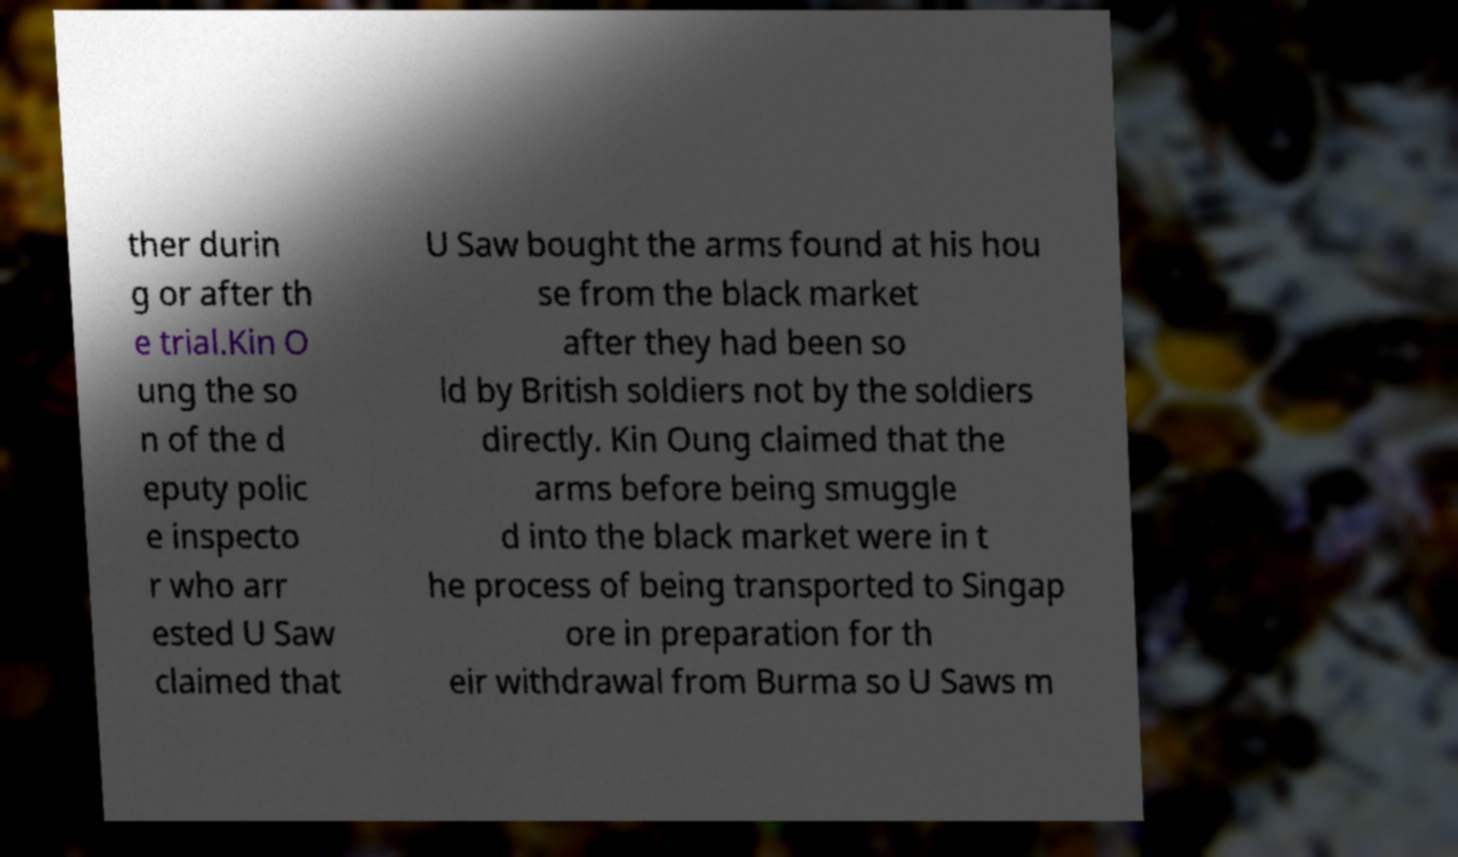Could you assist in decoding the text presented in this image and type it out clearly? ther durin g or after th e trial.Kin O ung the so n of the d eputy polic e inspecto r who arr ested U Saw claimed that U Saw bought the arms found at his hou se from the black market after they had been so ld by British soldiers not by the soldiers directly. Kin Oung claimed that the arms before being smuggle d into the black market were in t he process of being transported to Singap ore in preparation for th eir withdrawal from Burma so U Saws m 